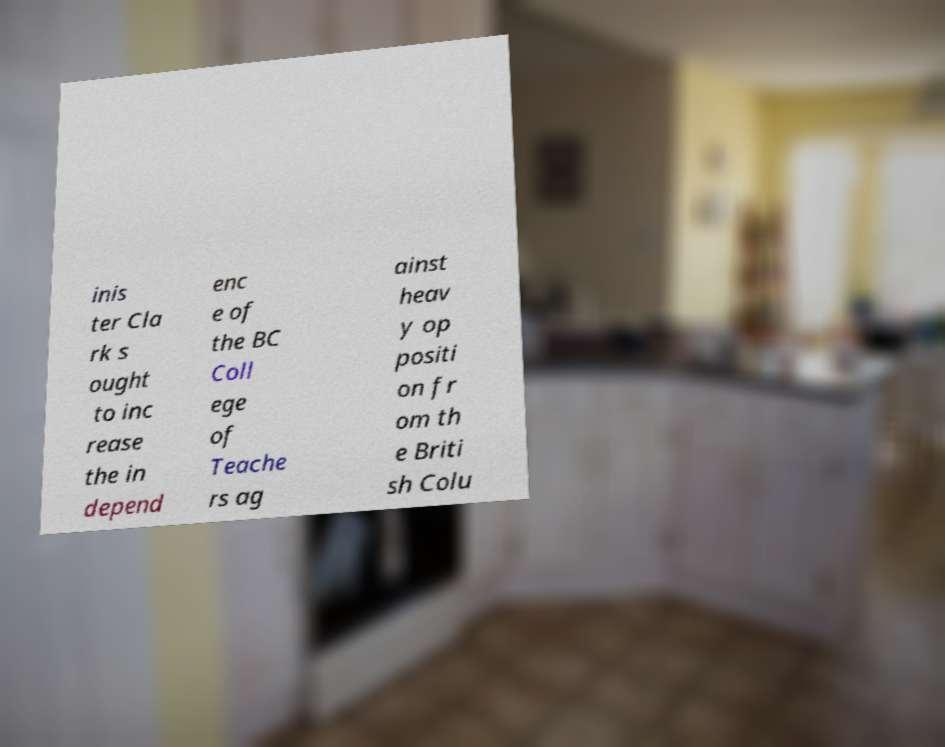Please identify and transcribe the text found in this image. inis ter Cla rk s ought to inc rease the in depend enc e of the BC Coll ege of Teache rs ag ainst heav y op positi on fr om th e Briti sh Colu 